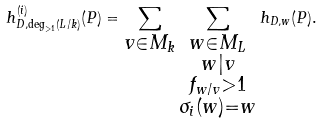Convert formula to latex. <formula><loc_0><loc_0><loc_500><loc_500>h _ { D , \deg _ { > 1 } ( L / k ) } ^ { ( i ) } ( P ) = \sum _ { \substack { v \in M _ { k } } } \sum _ { \substack { w \in M _ { L } \\ w | v \\ f _ { w / v } > 1 \\ \sigma _ { i } ( w ) = w } } h _ { D , w } ( P ) .</formula> 